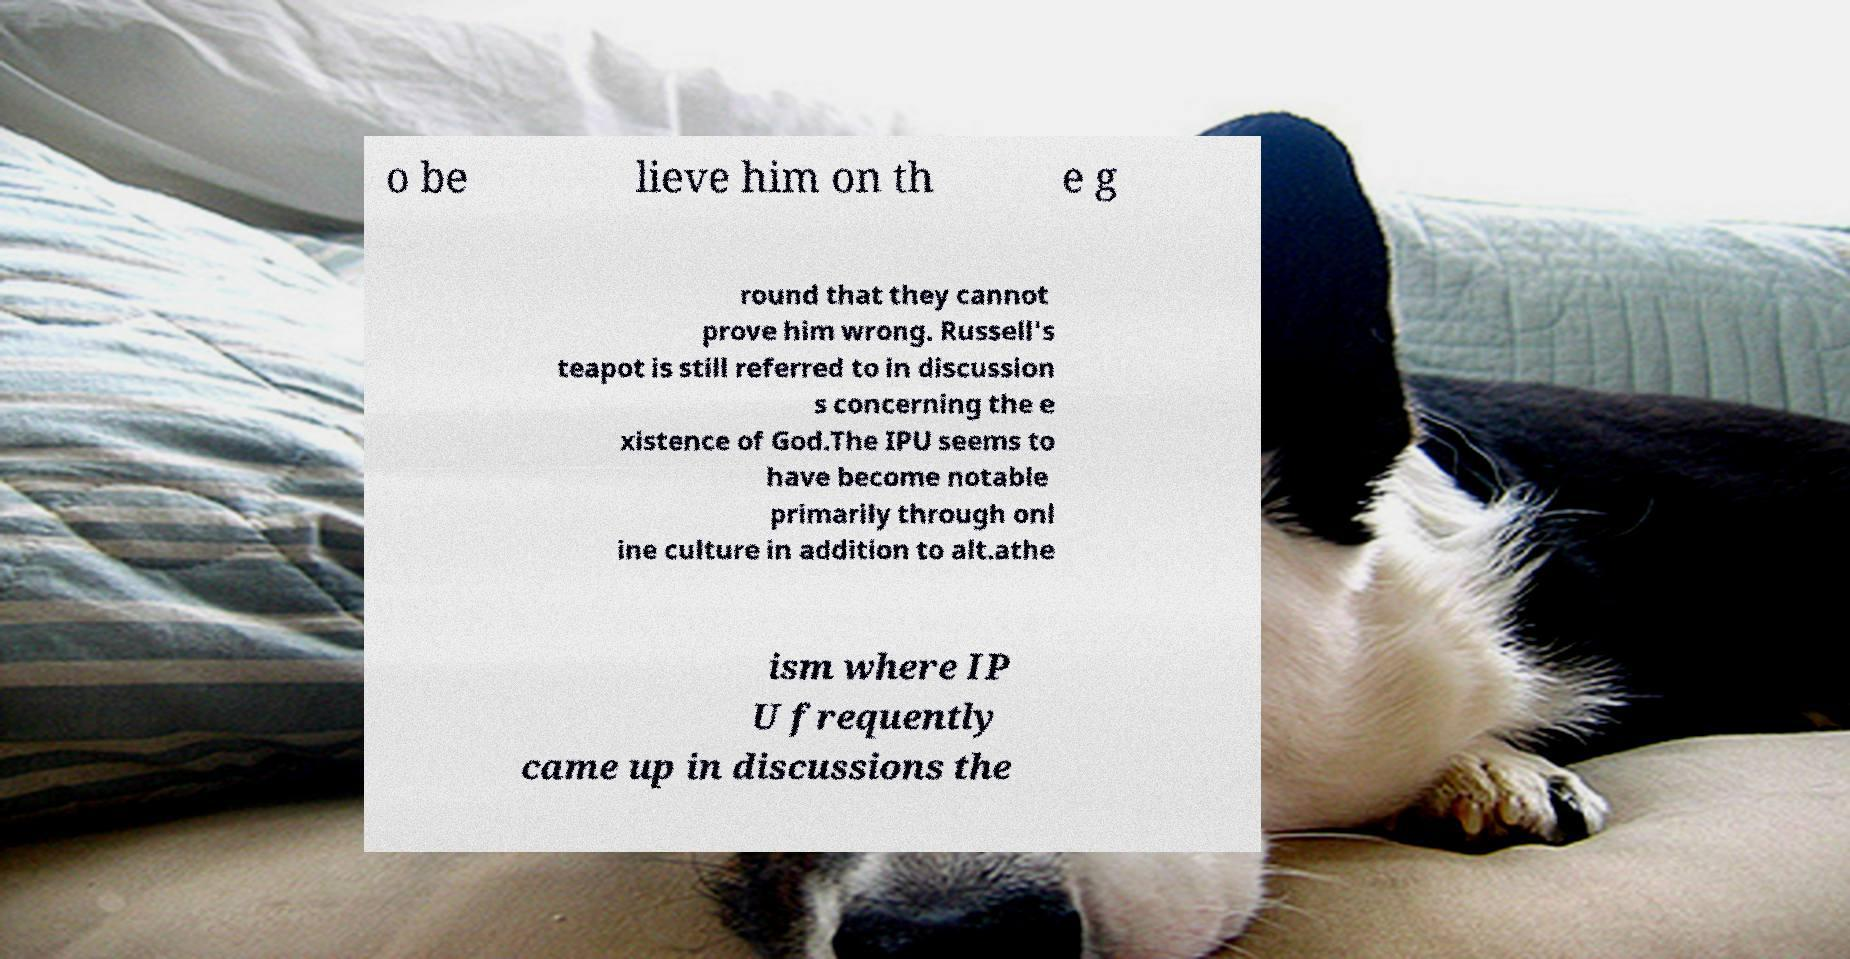Could you assist in decoding the text presented in this image and type it out clearly? o be lieve him on th e g round that they cannot prove him wrong. Russell's teapot is still referred to in discussion s concerning the e xistence of God.The IPU seems to have become notable primarily through onl ine culture in addition to alt.athe ism where IP U frequently came up in discussions the 